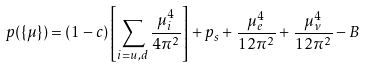<formula> <loc_0><loc_0><loc_500><loc_500>p ( \{ \mu \} ) = ( 1 - c ) \left [ \sum _ { i = u , d } \frac { \mu _ { i } ^ { 4 } } { 4 \pi ^ { 2 } } \right ] + p _ { s } + \frac { \mu _ { e } ^ { 4 } } { 1 2 \pi ^ { 2 } } + \frac { \mu _ { \nu } ^ { 4 } } { 1 2 \pi ^ { 2 } } - B</formula> 